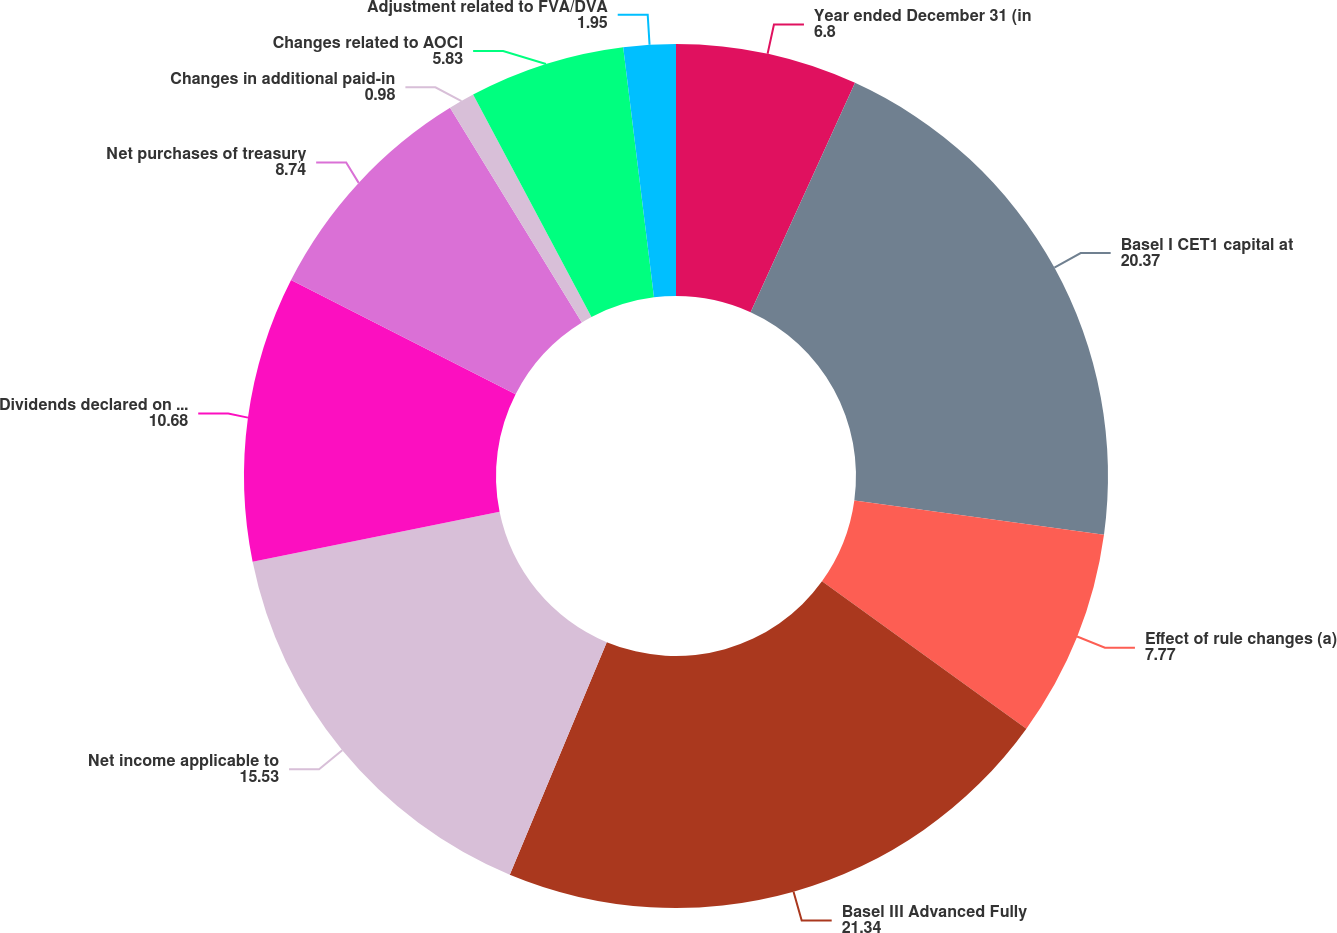<chart> <loc_0><loc_0><loc_500><loc_500><pie_chart><fcel>Year ended December 31 (in<fcel>Basel I CET1 capital at<fcel>Effect of rule changes (a)<fcel>Basel III Advanced Fully<fcel>Net income applicable to<fcel>Dividends declared on common<fcel>Net purchases of treasury<fcel>Changes in additional paid-in<fcel>Changes related to AOCI<fcel>Adjustment related to FVA/DVA<nl><fcel>6.8%<fcel>20.37%<fcel>7.77%<fcel>21.34%<fcel>15.53%<fcel>10.68%<fcel>8.74%<fcel>0.98%<fcel>5.83%<fcel>1.95%<nl></chart> 